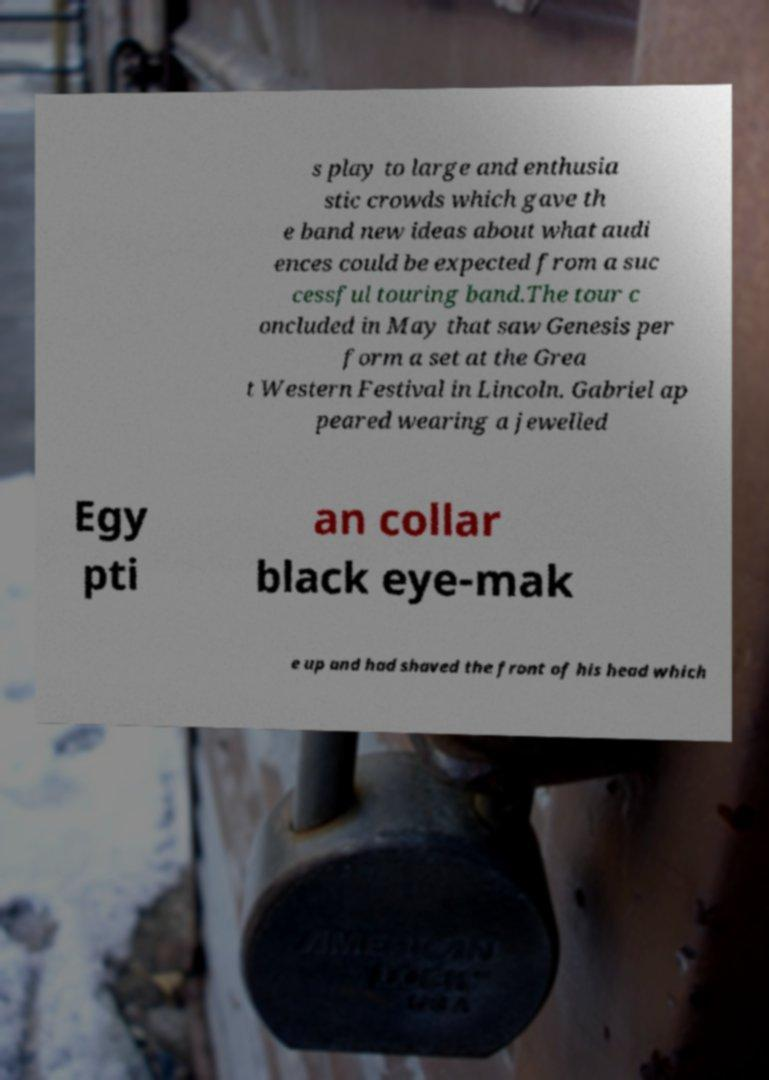Can you accurately transcribe the text from the provided image for me? s play to large and enthusia stic crowds which gave th e band new ideas about what audi ences could be expected from a suc cessful touring band.The tour c oncluded in May that saw Genesis per form a set at the Grea t Western Festival in Lincoln. Gabriel ap peared wearing a jewelled Egy pti an collar black eye-mak e up and had shaved the front of his head which 